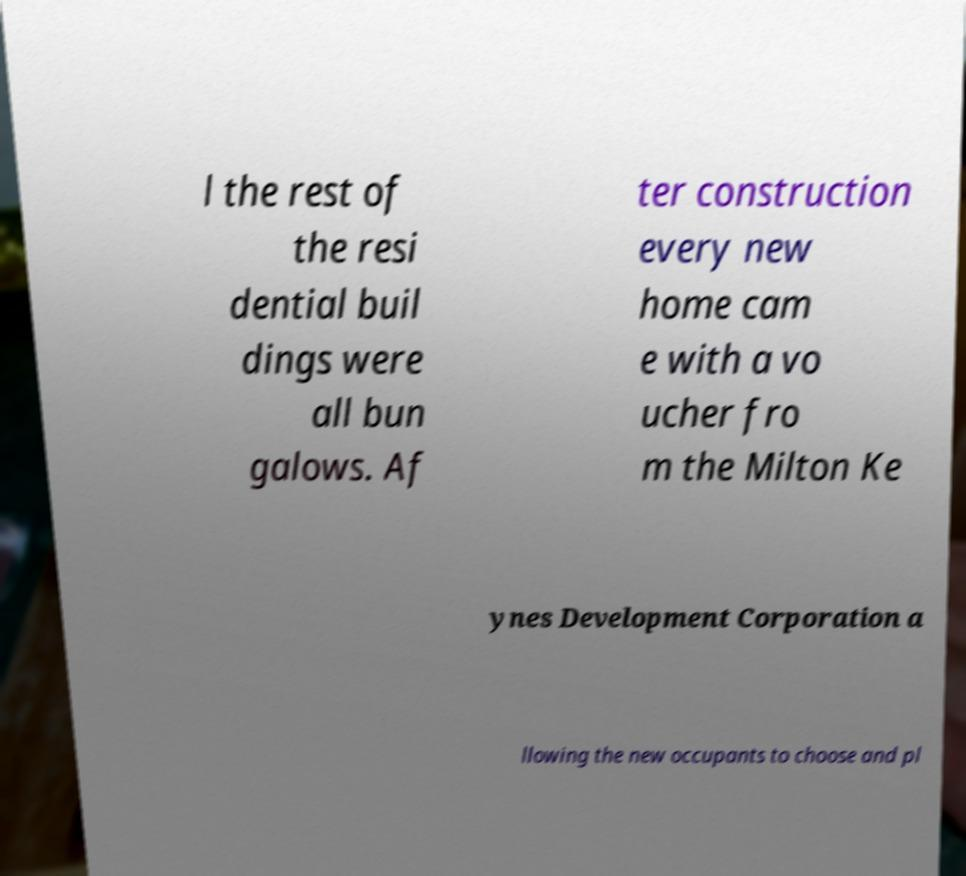For documentation purposes, I need the text within this image transcribed. Could you provide that? l the rest of the resi dential buil dings were all bun galows. Af ter construction every new home cam e with a vo ucher fro m the Milton Ke ynes Development Corporation a llowing the new occupants to choose and pl 